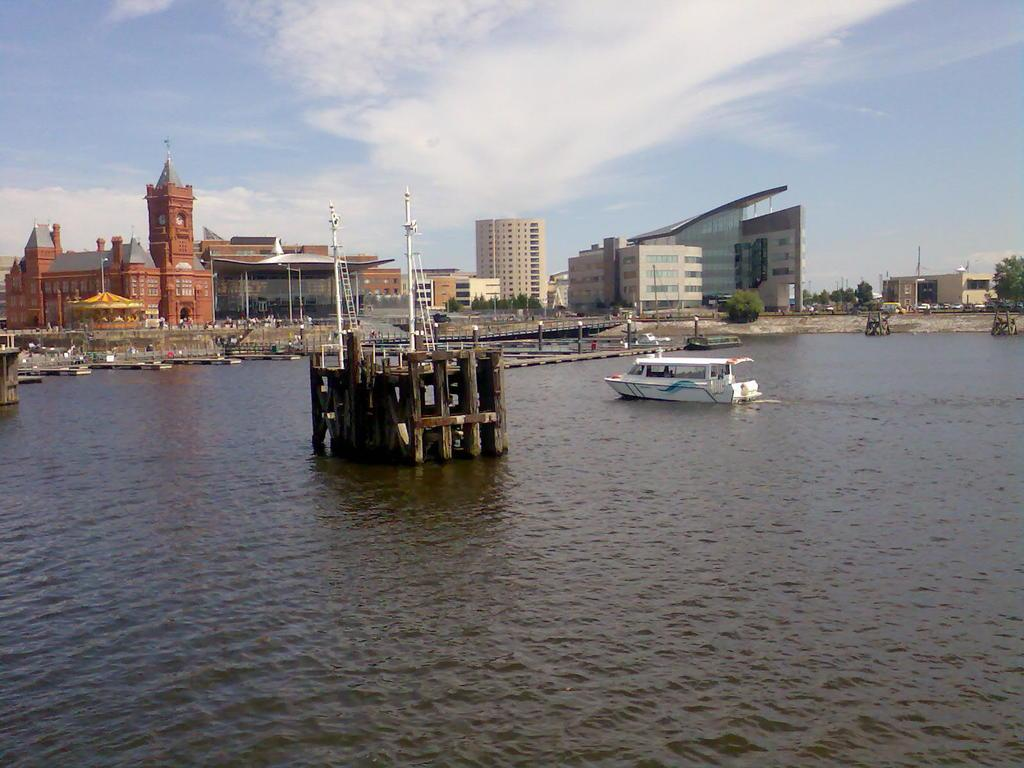What type of structure is present in the image? There is a castle in the image. What other structures can be seen in the image? There are buildings in the image. What mode of transportation is visible in the image? There is a boat in the image. What natural elements are present in the image? There is water and sand visible in the image. What type of vegetation can be seen in the image? There are trees in the image. How many parcels are being delivered to the castle in the image? There is no mention of parcels or delivery in the image; it only shows a castle, buildings, a boat, water, sand, and trees. 